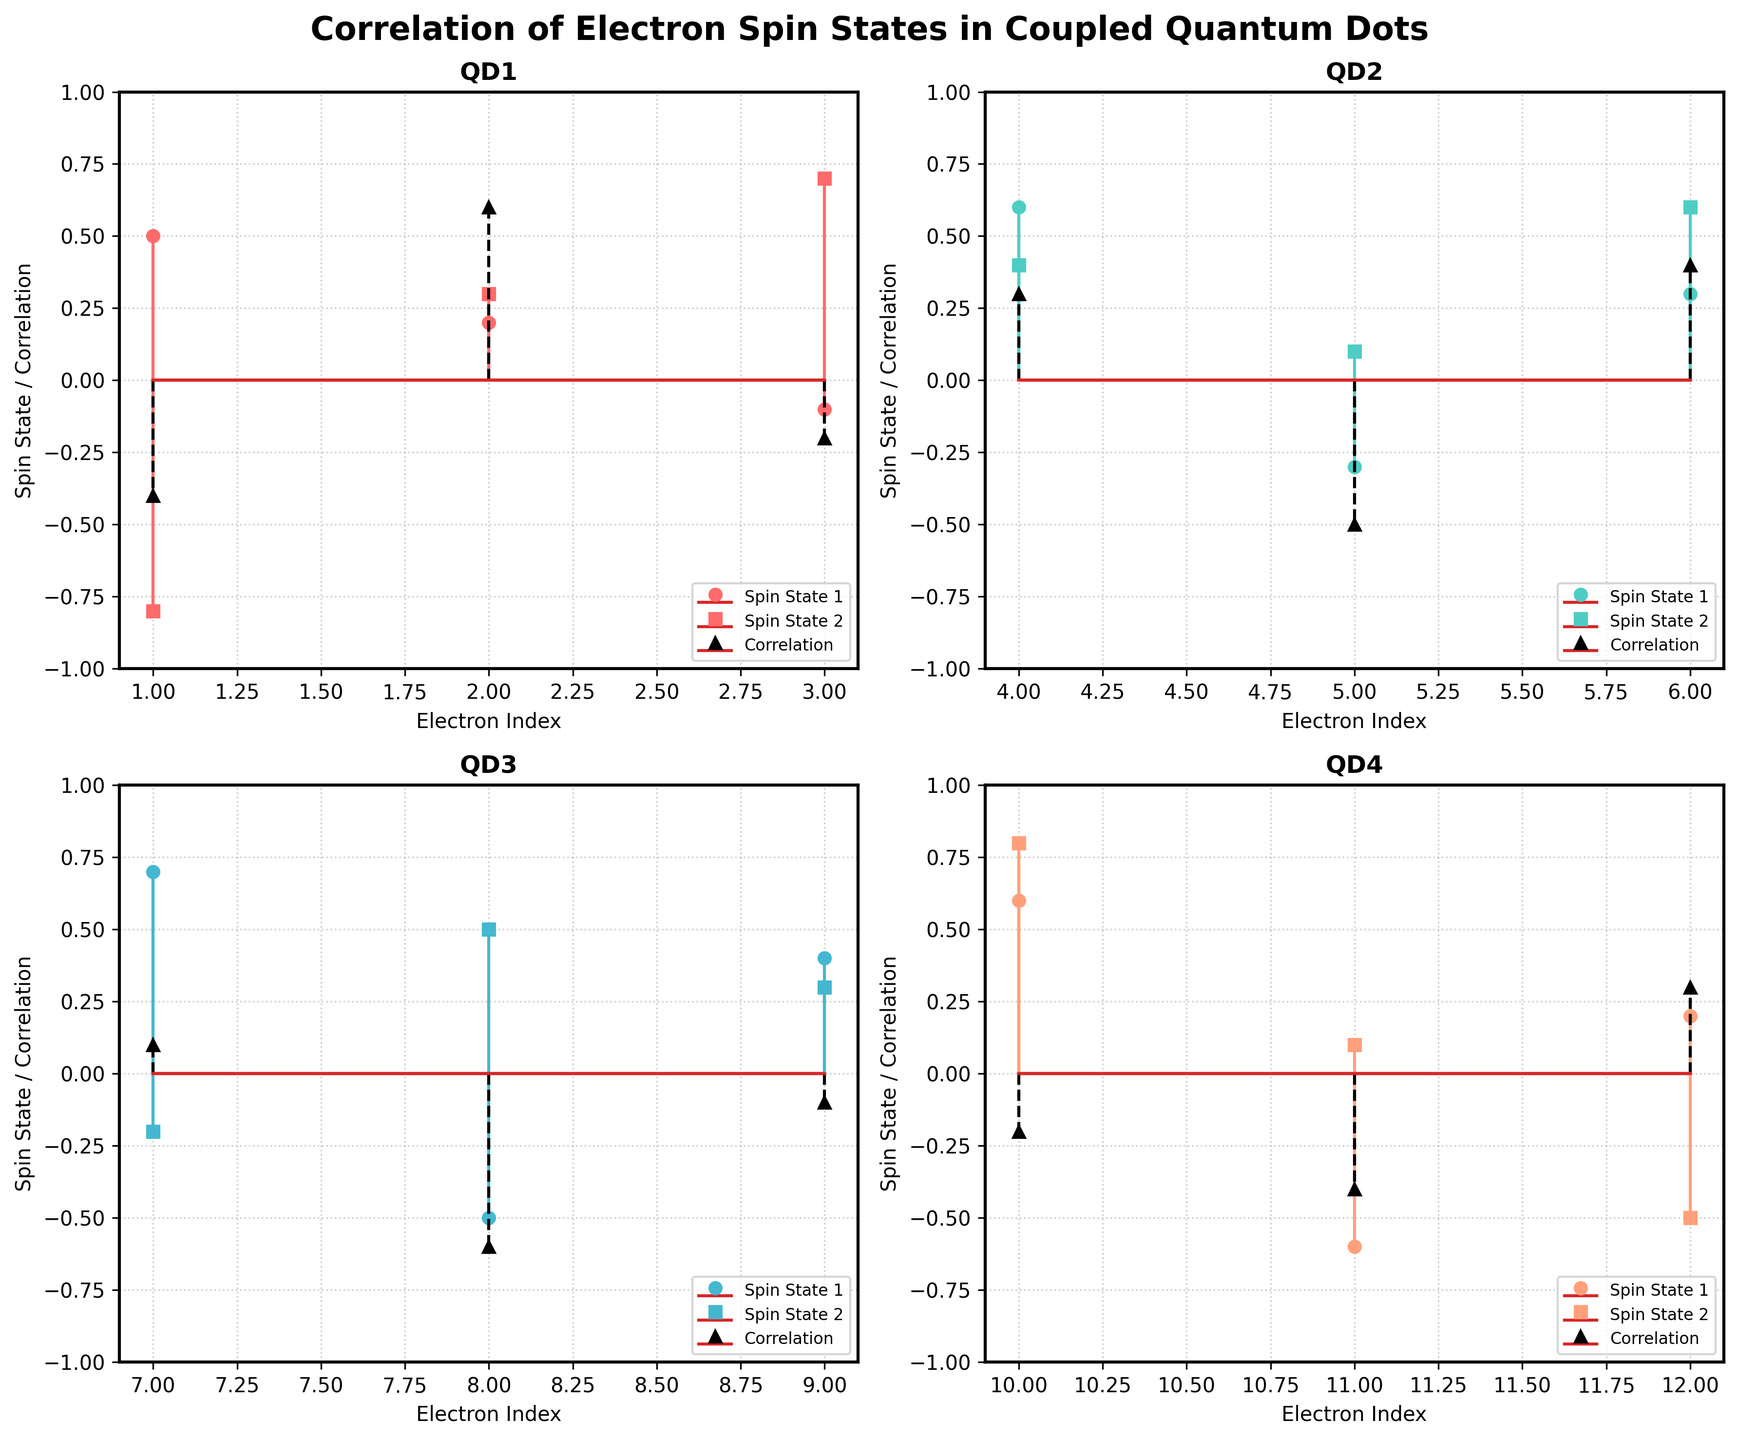How many electrons are represented in Quantum Dot 3? Count the number of stems this subplot has. There are 3 electron spin states displayed for Quantum Dot 3 in the subplot.
Answer: 3 What is the title of the figure? The title is displayed at the top center of the figure and reads 'Correlation of Electron Spin States in Coupled Quantum Dots'.
Answer: Correlation of Electron Spin States in Coupled Quantum Dots Which spin state in Quantum Dot 1 has the highest value? In the Quantum Dot 1 subplot, compare the values of Spin State 1 and Spin State 2. The highest value for Spin State 2 is 0.7.
Answer: Spin State 2 What color represents Quantum Dot 2 in the subplots? Identify the color of the line and markers in the subplot for Quantum Dot 2. The lines and markers for Quantum Dot 2 are in green.
Answer: Green What is the correlation value for the second electron in Quantum Dot 2? Locate the second electron in Quantum Dot 2 subplot and read the stem value for correlation which is represented by black dashed lines. The value is -0.5 for the second electron.
Answer: -0.5 For Quantum Dot 4, which electron index shows the highest correlation? Compare the correlation values (represented by black dashed lines) for all electrons in Quantum Dot 4. The highest correlation value is 0.3 at the electron index of 12.
Answer: 12 What is the average Spin State 1 value for Quantum Dot 1? Add the Spin State 1 values (0.5 + 0.2 - 0.1) and divide by the number of electrons (3). The sum is 0.6, and the average is 0.2.
Answer: 0.2 Which Quantum Dot shows the highest correlation overall? Compare the maximum correlation values for each Quantum Dot. Quantum Dot 2 has the highest observed correlation of 0.4.
Answer: Quantum Dot 2 Between Spin State 1 and Spin State 2 in Quantum Dot 2, which has a higher average value? Calculate the average of Spin State 1 values (0.6 - 0.3 + 0.3 = 0.6/3 = 0.2) and Spin State 2 values (0.4 + 0.1 + 0.6 = 1.1/3 = 0.367). Spin State 2 has a higher average value of 0.367.
Answer: Spin State 2 Is there any Quantum Dot where all the correlation values are negative? Check the correlation values in each quantum dot. For Quantum Dot 3, all the correlation values are 0.1, -0.6, -0.1, hence not all values are negative. No Quantum Dot satisfies the criteria.
Answer: No 